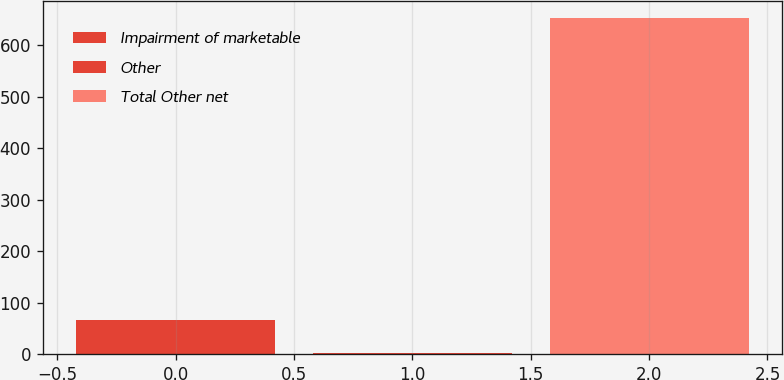Convert chart to OTSL. <chart><loc_0><loc_0><loc_500><loc_500><bar_chart><fcel>Impairment of marketable<fcel>Other<fcel>Total Other net<nl><fcel>66.2<fcel>1<fcel>653<nl></chart> 